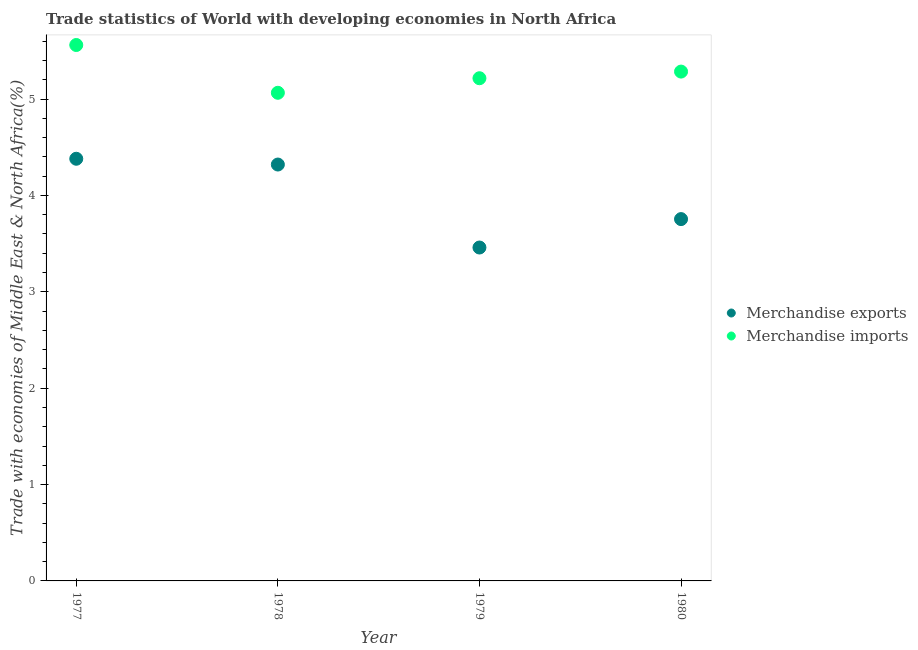How many different coloured dotlines are there?
Keep it short and to the point. 2. What is the merchandise exports in 1977?
Your answer should be very brief. 4.38. Across all years, what is the maximum merchandise exports?
Provide a succinct answer. 4.38. Across all years, what is the minimum merchandise imports?
Keep it short and to the point. 5.07. In which year was the merchandise imports minimum?
Provide a short and direct response. 1978. What is the total merchandise imports in the graph?
Provide a succinct answer. 21.13. What is the difference between the merchandise imports in 1977 and that in 1980?
Offer a terse response. 0.28. What is the difference between the merchandise imports in 1980 and the merchandise exports in 1977?
Your answer should be compact. 0.9. What is the average merchandise imports per year?
Make the answer very short. 5.28. In the year 1980, what is the difference between the merchandise exports and merchandise imports?
Make the answer very short. -1.53. What is the ratio of the merchandise exports in 1977 to that in 1980?
Provide a succinct answer. 1.17. Is the merchandise imports in 1978 less than that in 1979?
Your answer should be very brief. Yes. What is the difference between the highest and the second highest merchandise exports?
Keep it short and to the point. 0.06. What is the difference between the highest and the lowest merchandise exports?
Make the answer very short. 0.92. Is the sum of the merchandise imports in 1977 and 1980 greater than the maximum merchandise exports across all years?
Ensure brevity in your answer.  Yes. Is the merchandise imports strictly greater than the merchandise exports over the years?
Ensure brevity in your answer.  Yes. Is the merchandise exports strictly less than the merchandise imports over the years?
Ensure brevity in your answer.  Yes. What is the difference between two consecutive major ticks on the Y-axis?
Your answer should be very brief. 1. Are the values on the major ticks of Y-axis written in scientific E-notation?
Give a very brief answer. No. Does the graph contain grids?
Your answer should be very brief. No. How many legend labels are there?
Ensure brevity in your answer.  2. How are the legend labels stacked?
Your response must be concise. Vertical. What is the title of the graph?
Ensure brevity in your answer.  Trade statistics of World with developing economies in North Africa. What is the label or title of the X-axis?
Provide a short and direct response. Year. What is the label or title of the Y-axis?
Give a very brief answer. Trade with economies of Middle East & North Africa(%). What is the Trade with economies of Middle East & North Africa(%) in Merchandise exports in 1977?
Ensure brevity in your answer.  4.38. What is the Trade with economies of Middle East & North Africa(%) of Merchandise imports in 1977?
Provide a short and direct response. 5.56. What is the Trade with economies of Middle East & North Africa(%) of Merchandise exports in 1978?
Your answer should be compact. 4.32. What is the Trade with economies of Middle East & North Africa(%) in Merchandise imports in 1978?
Your answer should be very brief. 5.07. What is the Trade with economies of Middle East & North Africa(%) in Merchandise exports in 1979?
Offer a very short reply. 3.46. What is the Trade with economies of Middle East & North Africa(%) in Merchandise imports in 1979?
Offer a terse response. 5.22. What is the Trade with economies of Middle East & North Africa(%) of Merchandise exports in 1980?
Keep it short and to the point. 3.75. What is the Trade with economies of Middle East & North Africa(%) of Merchandise imports in 1980?
Provide a succinct answer. 5.29. Across all years, what is the maximum Trade with economies of Middle East & North Africa(%) in Merchandise exports?
Your response must be concise. 4.38. Across all years, what is the maximum Trade with economies of Middle East & North Africa(%) in Merchandise imports?
Offer a very short reply. 5.56. Across all years, what is the minimum Trade with economies of Middle East & North Africa(%) in Merchandise exports?
Keep it short and to the point. 3.46. Across all years, what is the minimum Trade with economies of Middle East & North Africa(%) in Merchandise imports?
Keep it short and to the point. 5.07. What is the total Trade with economies of Middle East & North Africa(%) in Merchandise exports in the graph?
Offer a very short reply. 15.92. What is the total Trade with economies of Middle East & North Africa(%) in Merchandise imports in the graph?
Your answer should be very brief. 21.13. What is the difference between the Trade with economies of Middle East & North Africa(%) in Merchandise imports in 1977 and that in 1978?
Make the answer very short. 0.5. What is the difference between the Trade with economies of Middle East & North Africa(%) in Merchandise exports in 1977 and that in 1979?
Give a very brief answer. 0.92. What is the difference between the Trade with economies of Middle East & North Africa(%) of Merchandise imports in 1977 and that in 1979?
Provide a succinct answer. 0.34. What is the difference between the Trade with economies of Middle East & North Africa(%) in Merchandise exports in 1977 and that in 1980?
Offer a very short reply. 0.63. What is the difference between the Trade with economies of Middle East & North Africa(%) in Merchandise imports in 1977 and that in 1980?
Keep it short and to the point. 0.28. What is the difference between the Trade with economies of Middle East & North Africa(%) in Merchandise exports in 1978 and that in 1979?
Give a very brief answer. 0.86. What is the difference between the Trade with economies of Middle East & North Africa(%) of Merchandise imports in 1978 and that in 1979?
Give a very brief answer. -0.15. What is the difference between the Trade with economies of Middle East & North Africa(%) in Merchandise exports in 1978 and that in 1980?
Give a very brief answer. 0.57. What is the difference between the Trade with economies of Middle East & North Africa(%) of Merchandise imports in 1978 and that in 1980?
Provide a short and direct response. -0.22. What is the difference between the Trade with economies of Middle East & North Africa(%) in Merchandise exports in 1979 and that in 1980?
Your answer should be compact. -0.29. What is the difference between the Trade with economies of Middle East & North Africa(%) in Merchandise imports in 1979 and that in 1980?
Offer a very short reply. -0.07. What is the difference between the Trade with economies of Middle East & North Africa(%) of Merchandise exports in 1977 and the Trade with economies of Middle East & North Africa(%) of Merchandise imports in 1978?
Keep it short and to the point. -0.68. What is the difference between the Trade with economies of Middle East & North Africa(%) in Merchandise exports in 1977 and the Trade with economies of Middle East & North Africa(%) in Merchandise imports in 1979?
Give a very brief answer. -0.84. What is the difference between the Trade with economies of Middle East & North Africa(%) in Merchandise exports in 1977 and the Trade with economies of Middle East & North Africa(%) in Merchandise imports in 1980?
Offer a very short reply. -0.9. What is the difference between the Trade with economies of Middle East & North Africa(%) in Merchandise exports in 1978 and the Trade with economies of Middle East & North Africa(%) in Merchandise imports in 1979?
Your answer should be very brief. -0.9. What is the difference between the Trade with economies of Middle East & North Africa(%) in Merchandise exports in 1978 and the Trade with economies of Middle East & North Africa(%) in Merchandise imports in 1980?
Give a very brief answer. -0.96. What is the difference between the Trade with economies of Middle East & North Africa(%) in Merchandise exports in 1979 and the Trade with economies of Middle East & North Africa(%) in Merchandise imports in 1980?
Give a very brief answer. -1.83. What is the average Trade with economies of Middle East & North Africa(%) in Merchandise exports per year?
Give a very brief answer. 3.98. What is the average Trade with economies of Middle East & North Africa(%) in Merchandise imports per year?
Make the answer very short. 5.28. In the year 1977, what is the difference between the Trade with economies of Middle East & North Africa(%) in Merchandise exports and Trade with economies of Middle East & North Africa(%) in Merchandise imports?
Your answer should be very brief. -1.18. In the year 1978, what is the difference between the Trade with economies of Middle East & North Africa(%) of Merchandise exports and Trade with economies of Middle East & North Africa(%) of Merchandise imports?
Provide a succinct answer. -0.74. In the year 1979, what is the difference between the Trade with economies of Middle East & North Africa(%) in Merchandise exports and Trade with economies of Middle East & North Africa(%) in Merchandise imports?
Offer a terse response. -1.76. In the year 1980, what is the difference between the Trade with economies of Middle East & North Africa(%) in Merchandise exports and Trade with economies of Middle East & North Africa(%) in Merchandise imports?
Offer a very short reply. -1.53. What is the ratio of the Trade with economies of Middle East & North Africa(%) in Merchandise exports in 1977 to that in 1978?
Offer a terse response. 1.01. What is the ratio of the Trade with economies of Middle East & North Africa(%) in Merchandise imports in 1977 to that in 1978?
Provide a succinct answer. 1.1. What is the ratio of the Trade with economies of Middle East & North Africa(%) in Merchandise exports in 1977 to that in 1979?
Keep it short and to the point. 1.27. What is the ratio of the Trade with economies of Middle East & North Africa(%) of Merchandise imports in 1977 to that in 1979?
Your answer should be very brief. 1.07. What is the ratio of the Trade with economies of Middle East & North Africa(%) of Merchandise exports in 1977 to that in 1980?
Keep it short and to the point. 1.17. What is the ratio of the Trade with economies of Middle East & North Africa(%) of Merchandise imports in 1977 to that in 1980?
Offer a terse response. 1.05. What is the ratio of the Trade with economies of Middle East & North Africa(%) of Merchandise exports in 1978 to that in 1979?
Give a very brief answer. 1.25. What is the ratio of the Trade with economies of Middle East & North Africa(%) in Merchandise imports in 1978 to that in 1979?
Ensure brevity in your answer.  0.97. What is the ratio of the Trade with economies of Middle East & North Africa(%) in Merchandise exports in 1978 to that in 1980?
Your answer should be very brief. 1.15. What is the ratio of the Trade with economies of Middle East & North Africa(%) in Merchandise imports in 1978 to that in 1980?
Your answer should be compact. 0.96. What is the ratio of the Trade with economies of Middle East & North Africa(%) of Merchandise exports in 1979 to that in 1980?
Ensure brevity in your answer.  0.92. What is the ratio of the Trade with economies of Middle East & North Africa(%) of Merchandise imports in 1979 to that in 1980?
Your answer should be compact. 0.99. What is the difference between the highest and the second highest Trade with economies of Middle East & North Africa(%) of Merchandise imports?
Offer a very short reply. 0.28. What is the difference between the highest and the lowest Trade with economies of Middle East & North Africa(%) of Merchandise exports?
Offer a very short reply. 0.92. What is the difference between the highest and the lowest Trade with economies of Middle East & North Africa(%) of Merchandise imports?
Your answer should be compact. 0.5. 